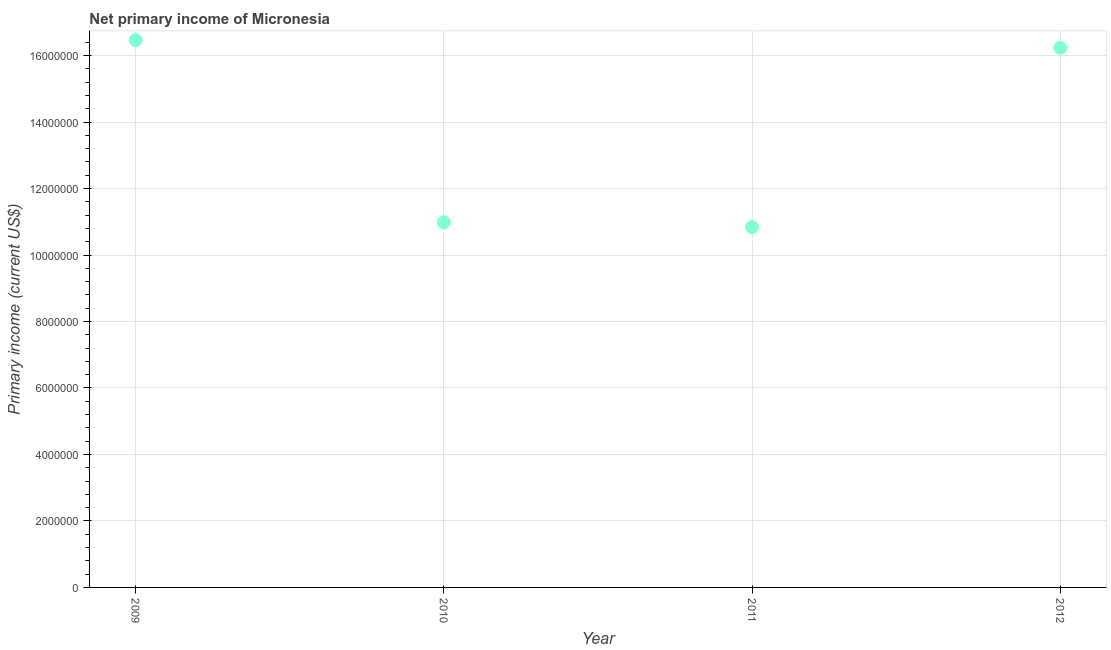What is the amount of primary income in 2009?
Keep it short and to the point. 1.65e+07. Across all years, what is the maximum amount of primary income?
Your response must be concise. 1.65e+07. Across all years, what is the minimum amount of primary income?
Give a very brief answer. 1.08e+07. In which year was the amount of primary income maximum?
Make the answer very short. 2009. What is the sum of the amount of primary income?
Your answer should be compact. 5.45e+07. What is the difference between the amount of primary income in 2009 and 2010?
Your answer should be very brief. 5.48e+06. What is the average amount of primary income per year?
Keep it short and to the point. 1.36e+07. What is the median amount of primary income?
Your answer should be compact. 1.36e+07. What is the ratio of the amount of primary income in 2010 to that in 2011?
Your answer should be very brief. 1.01. What is the difference between the highest and the second highest amount of primary income?
Your answer should be very brief. 2.32e+05. What is the difference between the highest and the lowest amount of primary income?
Your answer should be very brief. 5.62e+06. How many dotlines are there?
Your response must be concise. 1. How many years are there in the graph?
Offer a very short reply. 4. What is the title of the graph?
Ensure brevity in your answer.  Net primary income of Micronesia. What is the label or title of the X-axis?
Provide a succinct answer. Year. What is the label or title of the Y-axis?
Give a very brief answer. Primary income (current US$). What is the Primary income (current US$) in 2009?
Make the answer very short. 1.65e+07. What is the Primary income (current US$) in 2010?
Your response must be concise. 1.10e+07. What is the Primary income (current US$) in 2011?
Your answer should be compact. 1.08e+07. What is the Primary income (current US$) in 2012?
Ensure brevity in your answer.  1.62e+07. What is the difference between the Primary income (current US$) in 2009 and 2010?
Offer a very short reply. 5.48e+06. What is the difference between the Primary income (current US$) in 2009 and 2011?
Keep it short and to the point. 5.62e+06. What is the difference between the Primary income (current US$) in 2009 and 2012?
Your answer should be compact. 2.32e+05. What is the difference between the Primary income (current US$) in 2010 and 2011?
Provide a short and direct response. 1.46e+05. What is the difference between the Primary income (current US$) in 2010 and 2012?
Provide a succinct answer. -5.25e+06. What is the difference between the Primary income (current US$) in 2011 and 2012?
Your response must be concise. -5.39e+06. What is the ratio of the Primary income (current US$) in 2009 to that in 2010?
Provide a short and direct response. 1.5. What is the ratio of the Primary income (current US$) in 2009 to that in 2011?
Your response must be concise. 1.52. What is the ratio of the Primary income (current US$) in 2009 to that in 2012?
Make the answer very short. 1.01. What is the ratio of the Primary income (current US$) in 2010 to that in 2012?
Offer a very short reply. 0.68. What is the ratio of the Primary income (current US$) in 2011 to that in 2012?
Ensure brevity in your answer.  0.67. 